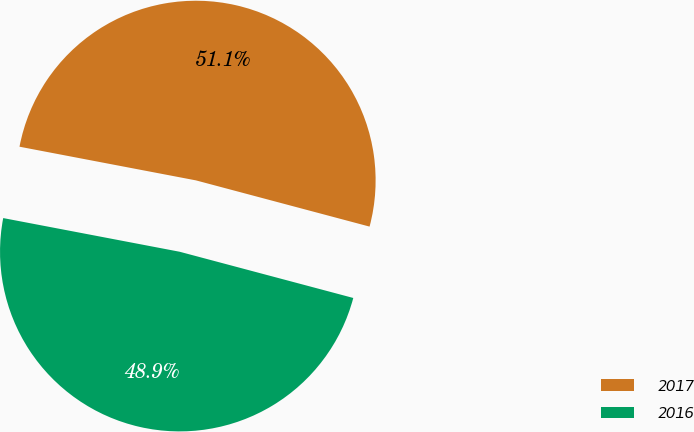<chart> <loc_0><loc_0><loc_500><loc_500><pie_chart><fcel>2017<fcel>2016<nl><fcel>51.14%<fcel>48.86%<nl></chart> 